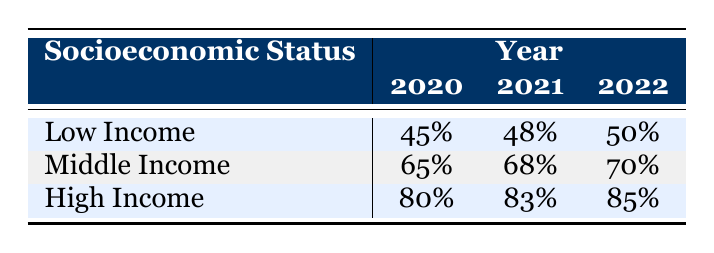What was the participation rate for Low Income students in 2020? The participation rate for Low Income students in 2020 is listed in the table under the "2020" column for "Low Income," which shows 45%.
Answer: 45% What is the participation rate for High Income students in 2021? The participation rate for High Income students in 2021 can be found in the "2021" column for "High Income," which shows 83%.
Answer: 83% Which socioeconomic status had the highest participation rate in 2022? To determine this, we check the "2022" column for each socioeconomic status: Low Income has 50%, Middle Income has 70%, and High Income has 85%. High Income has the highest rate at 85%.
Answer: High Income What is the average participation rate across all socioeconomic statuses for the year 2020? To calculate the average for 2020, we sum the participation rates: 45% (Low Income) + 65% (Middle Income) + 80% (High Income) = 190%, and then divide by 3, which gives us an average of 63.33%.
Answer: 63.33% Did the participation rate for Middle Income students increase from 2020 to 2022? The rates can be found in the table: Middle Income was 65% in 2020 and increased to 70% in 2022. Since 70% is greater than 65%, it shows an increase.
Answer: Yes Is the difference in participation rates for Low Income students from 2021 to 2022 greater than for High Income students in the same years? The difference for Low Income students is 50% - 48% = 2%, and for High Income students, it is 85% - 83% = 2%. Both differences are the same at 2%, so they are not greater.
Answer: No What percentage of Middle Income students participated in extracurricular activities in 2021? The participation rate for Middle Income students in 2021 is directly listed in the table under the "2021" column for "Middle Income," which shows 68%.
Answer: 68% What was the total participation rate across all socioeconomic statuses in 2021? To find the total for 2021, we sum the rates: 48% (Low Income) + 68% (Middle Income) + 83% (High Income) = 199%.
Answer: 199% What was the increase in participation rate for High Income students from 2020 to 2021? The participation rates in the table show 80% for 2020 and 83% for 2021. The increase can be calculated as 83% - 80% = 3%.
Answer: 3% 